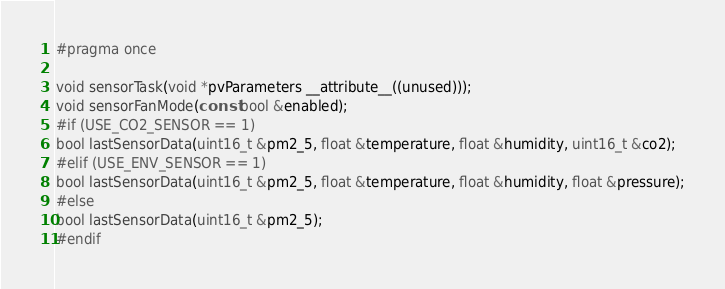<code> <loc_0><loc_0><loc_500><loc_500><_C_>#pragma once

void sensorTask(void *pvParameters __attribute__((unused)));
void sensorFanMode(const bool &enabled);
#if (USE_CO2_SENSOR == 1)
bool lastSensorData(uint16_t &pm2_5, float &temperature, float &humidity, uint16_t &co2);
#elif (USE_ENV_SENSOR == 1)
bool lastSensorData(uint16_t &pm2_5, float &temperature, float &humidity, float &pressure);
#else
bool lastSensorData(uint16_t &pm2_5);
#endif
</code> 